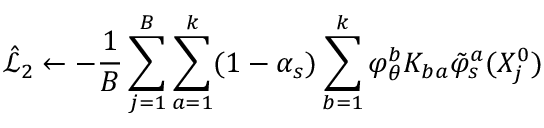Convert formula to latex. <formula><loc_0><loc_0><loc_500><loc_500>\hat { \mathcal { L } } _ { 2 } \gets - \frac { 1 } { B } \sum _ { j = 1 } ^ { B } \sum _ { a = 1 } ^ { k } ( 1 - \alpha _ { s } ) \sum _ { b = 1 } ^ { k } \varphi _ { \theta } ^ { b } K _ { b a } \tilde { \varphi } _ { s } ^ { a } ( X _ { j } ^ { 0 } )</formula> 